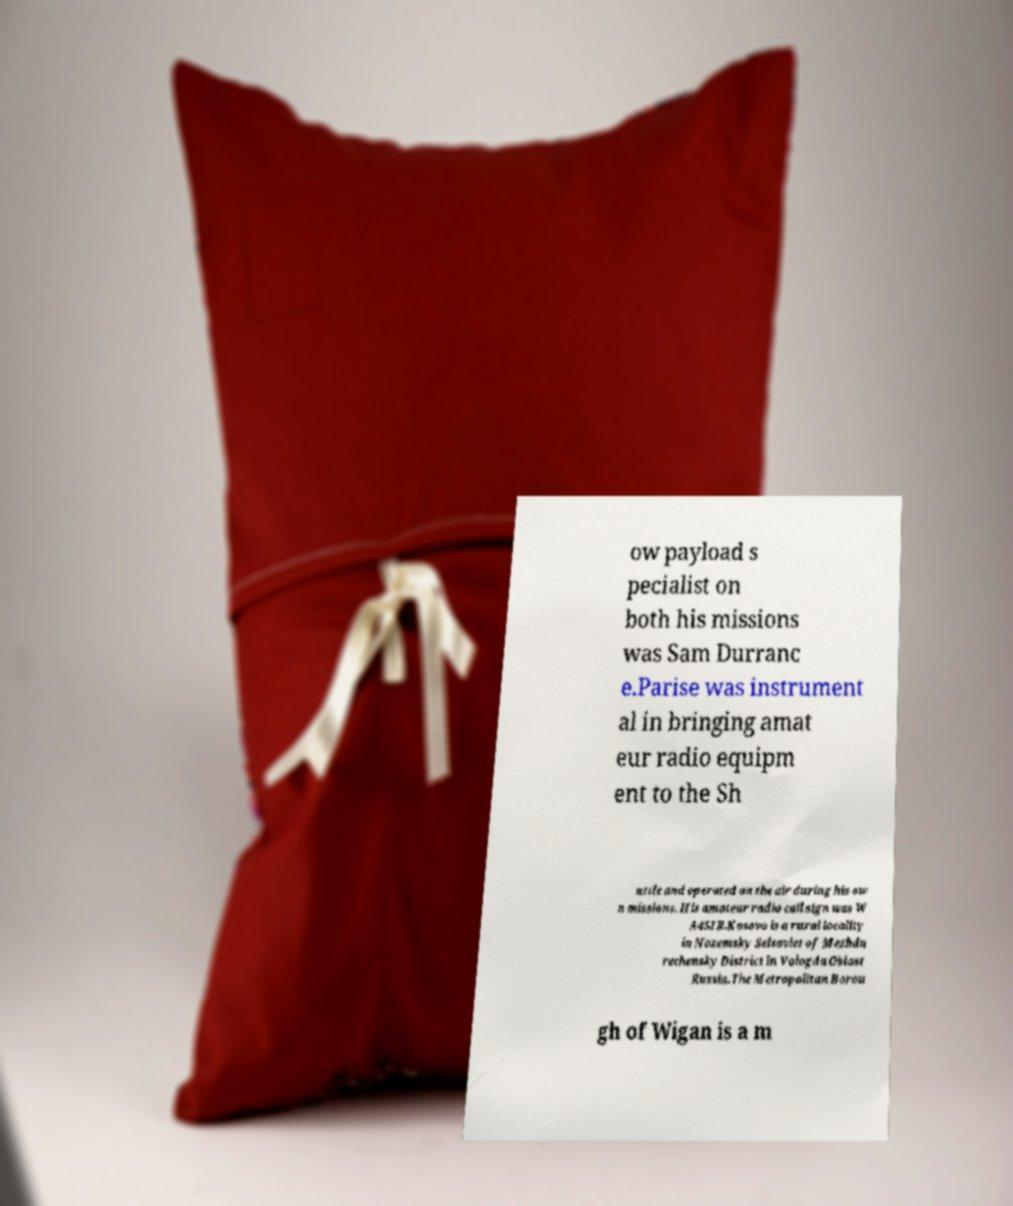I need the written content from this picture converted into text. Can you do that? ow payload s pecialist on both his missions was Sam Durranc e.Parise was instrument al in bringing amat eur radio equipm ent to the Sh uttle and operated on the air during his ow n missions. His amateur radio call sign was W A4SIR.Kosovo is a rural locality in Nozemsky Selsoviet of Mezhdu rechensky District in Vologda Oblast Russia.The Metropolitan Borou gh of Wigan is a m 